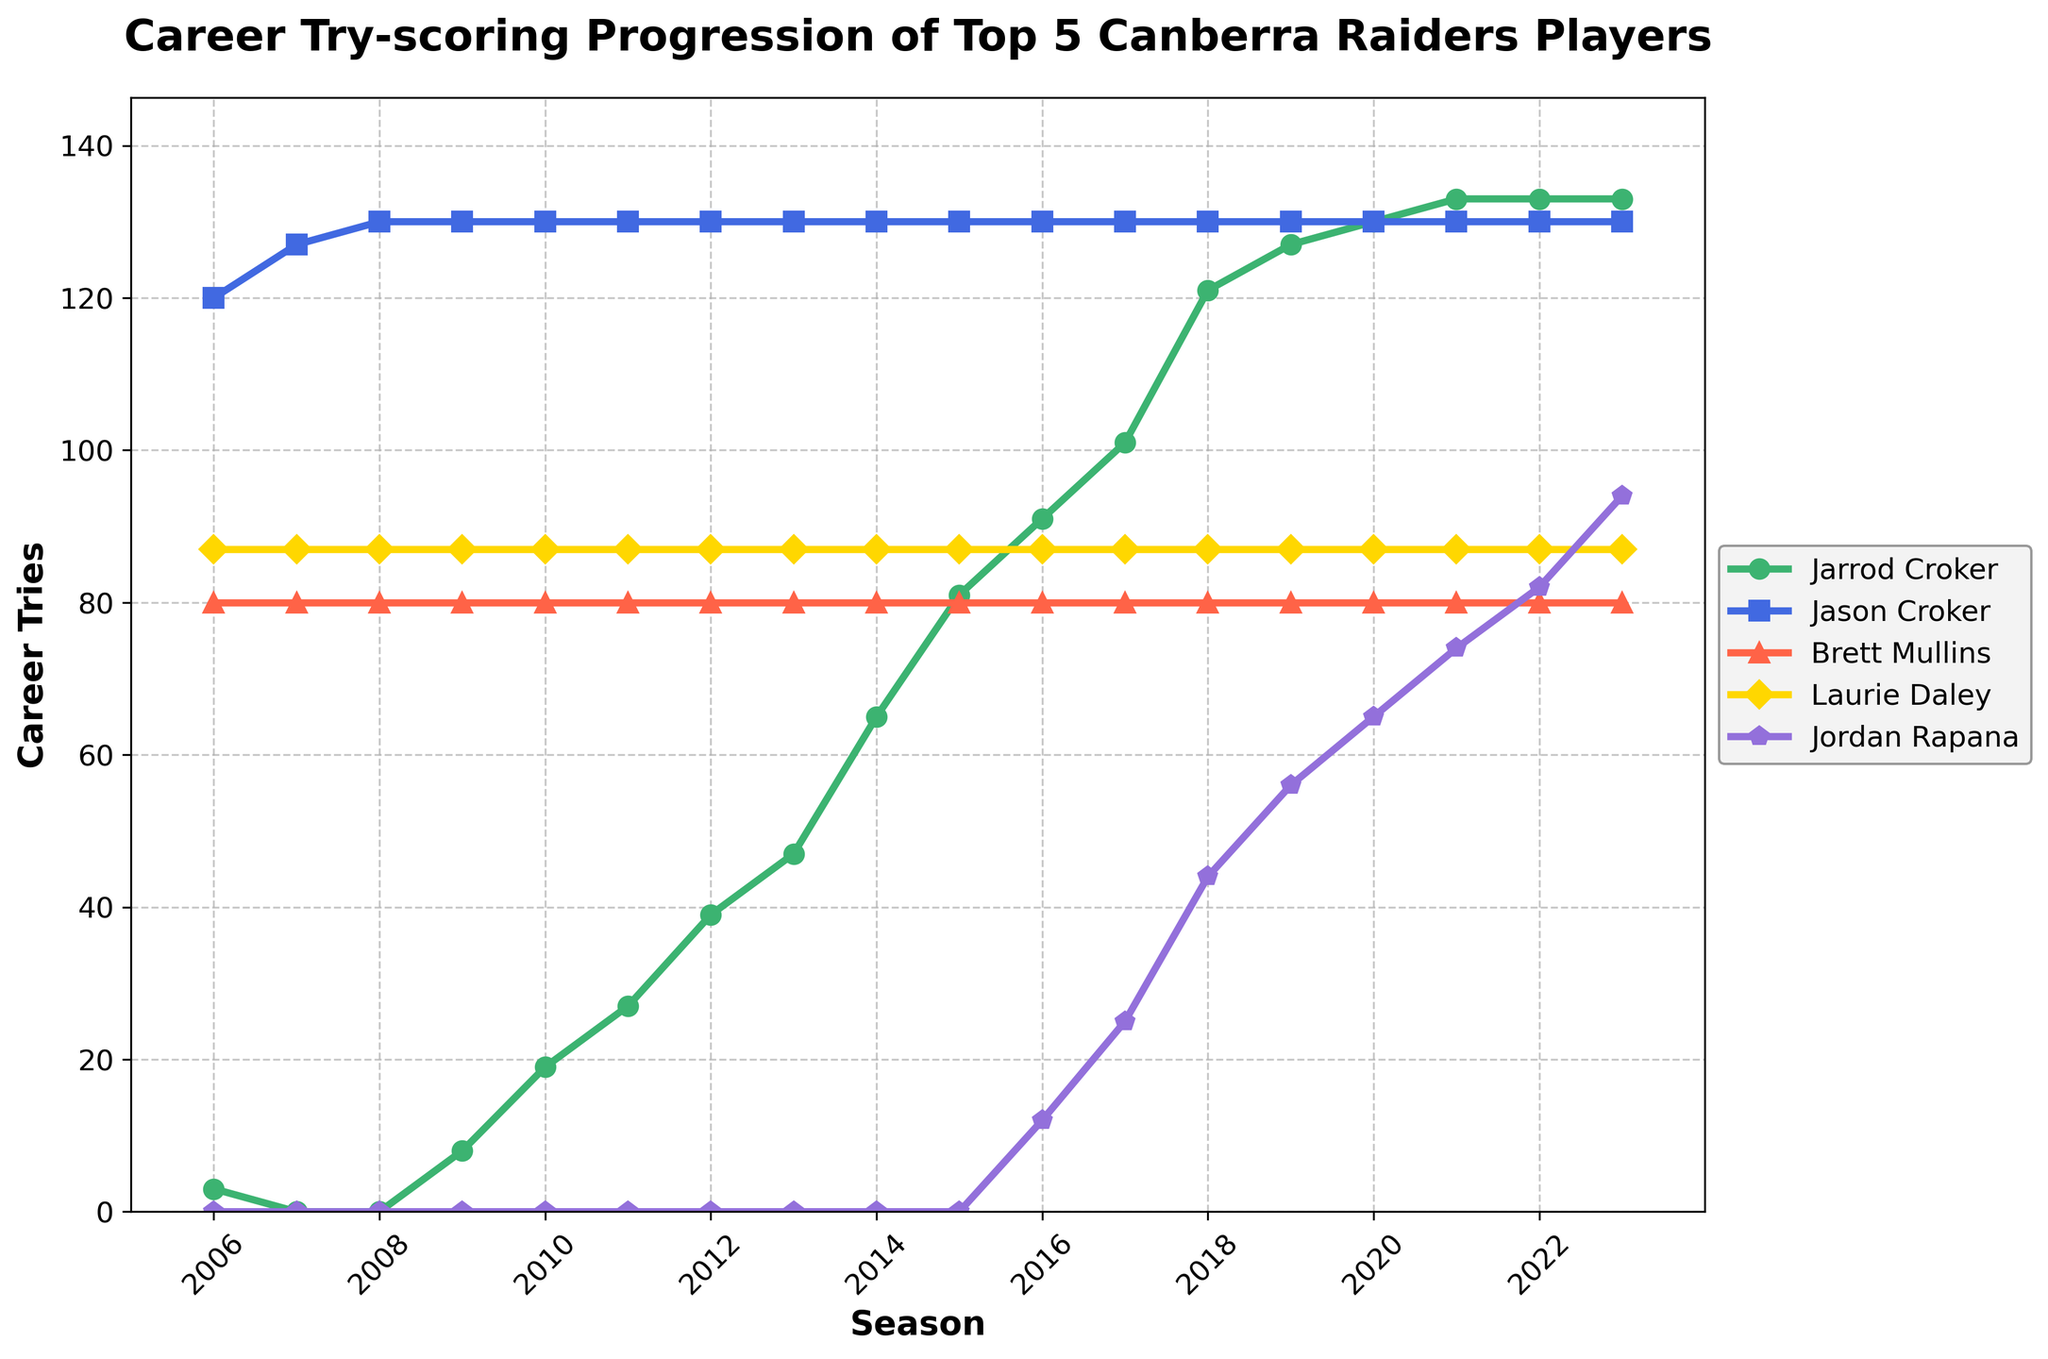Which player has the highest career tries in 2023? By looking at the endpoints of each player's line in 2023, we can see that Jarrod Croker has the highest value at 133 tries.
Answer: Jarrod Croker How many tries did Laurie Daley score in his career by 2009? The data shows Laurie Daley scored 87 tries consistently across all seasons, including 2009.
Answer: 87 Compare the progression of tries scored by Jarrod Croker and Jordan Rapana between 2014 and 2018. Which player had a larger increase? Jarrod Croker's tries increased from 65 in 2014 to 121 in 2018 (increase of 56), while Jordan Rapana's tries increased from 0 to 44 in the same period (increase of 44). Therefore, Jarrod Croker had a larger increase.
Answer: Jarrod Croker What is the difference in career tries between Brett Mullins and Laurie Daley in 2015? Since Brett Mullins and Laurie Daley both consistently scored 80 and 87 tries respectively, the difference in 2015 is 87 - 80 = 7.
Answer: 7 What was the average number of tries scored by Jason Croker over the entire timeline? Summing Jason Croker's tries from 2006 to 2023 (each 130 tries) and dividing by the number of seasons (2023-2006+1 = 18) gives us an average: 130 * 18 / 18 = 130.
Answer: 130 Which player showed the steepest progression in tries scored from 2016 to 2018? By observing the steepness of the lines, Jordan Rapana goes from 12 tries in 2016 to 44 tries in 2018, an increase of 32 tries in two years, which is steeper compared to the other players in the same period.
Answer: Jordan Rapana Did any player's total career tries remain constant through the timeline? Yes, Brett Mullins and Laurie Daley’s tries remained constant at 80 and 87 respectively throughout the entire timeline.
Answer: Yes, Brett Mullins and Laurie Daley How many tries did Jarrod Croker score from 2010 to 2016? From the data: 
2010: 19
2011: 27
2012: 39
2013: 47
2014: 65
2015: 81
2016: 91
Total = 19 + 27 + 39 + 47 + 65 + 81 + 91 = 369.
Answer: 369 Across which seasons did Jarrod Croker score exactly the same number of tries as Jason Croker (130) on the graph? In 2020, 2021, 2022, and 2023, Jarrod Croker’s total career tries (133, 133, 133, and 133 respectively) are only reached after surpassing 130 which matches with Jason Croker’s 130 tries.
Answer: 2020, 2021, 2022, and 2023 